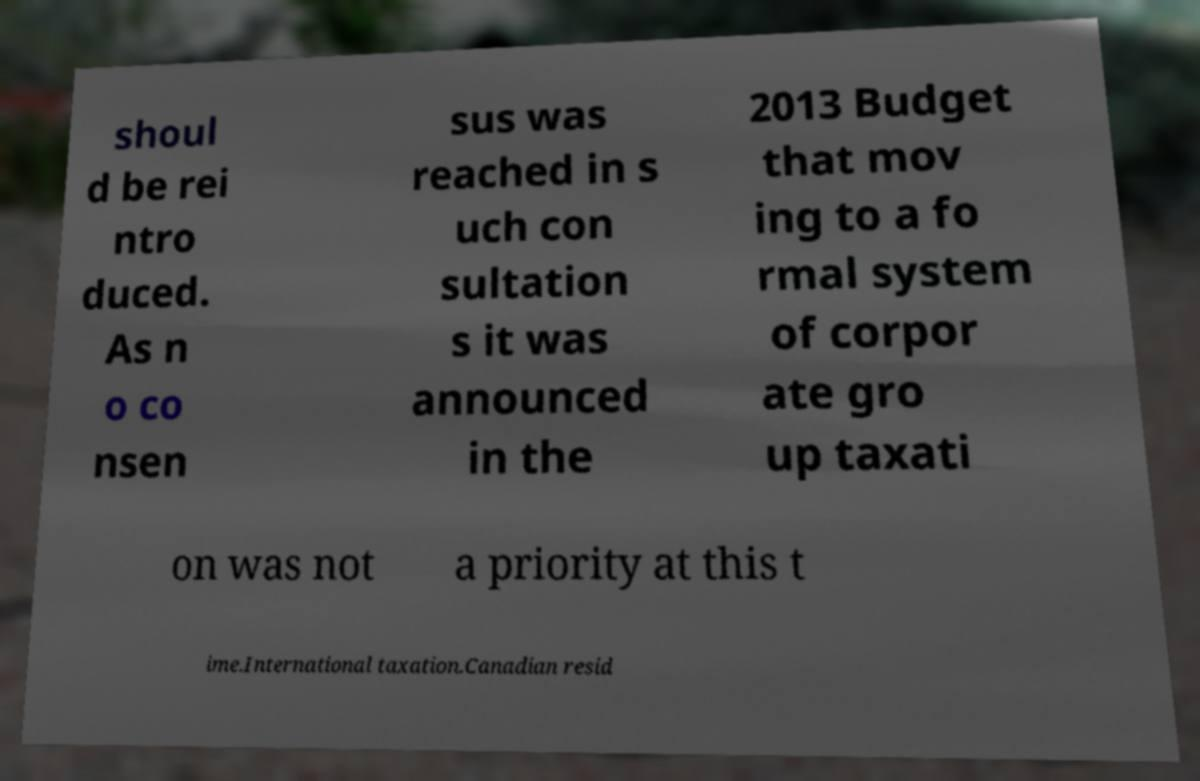Please read and relay the text visible in this image. What does it say? shoul d be rei ntro duced. As n o co nsen sus was reached in s uch con sultation s it was announced in the 2013 Budget that mov ing to a fo rmal system of corpor ate gro up taxati on was not a priority at this t ime.International taxation.Canadian resid 